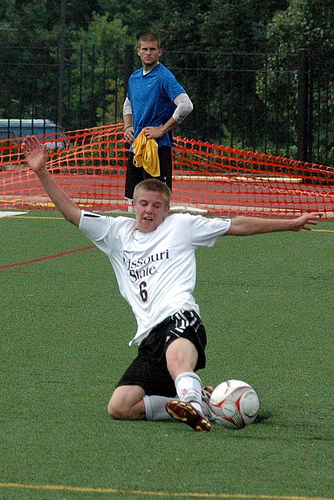<image>
Can you confirm if the player is under the footbal? No. The player is not positioned under the footbal. The vertical relationship between these objects is different. 